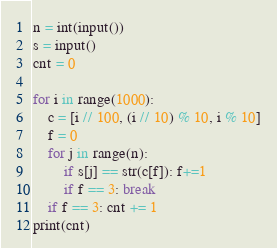<code> <loc_0><loc_0><loc_500><loc_500><_Python_>n = int(input())
s = input()
cnt = 0

for i in range(1000):
    c = [i // 100, (i // 10) % 10, i % 10]
    f = 0
    for j in range(n):
        if s[j] == str(c[f]): f+=1
        if f == 3: break
    if f == 3: cnt += 1
print(cnt)</code> 